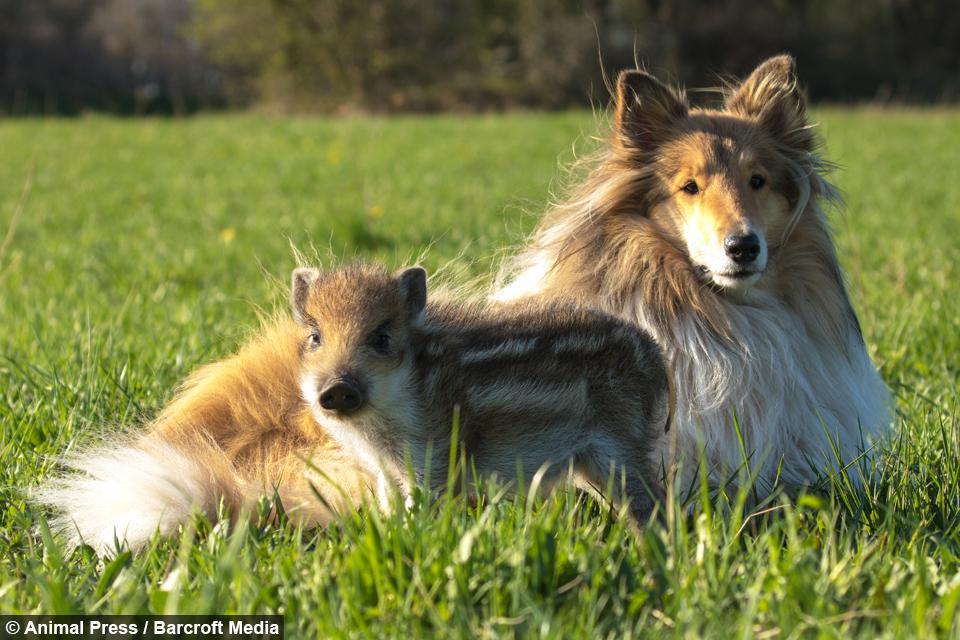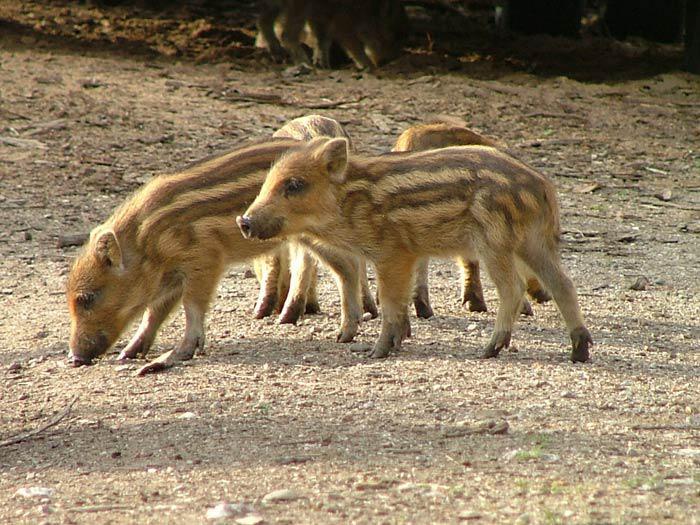The first image is the image on the left, the second image is the image on the right. Assess this claim about the two images: "One of the animals in the image on the left is not striped.". Correct or not? Answer yes or no. Yes. The first image is the image on the left, the second image is the image on the right. Examine the images to the left and right. Is the description "An image shows just one striped baby wild pig, which is turned leftward and standing on brown ground." accurate? Answer yes or no. No. 